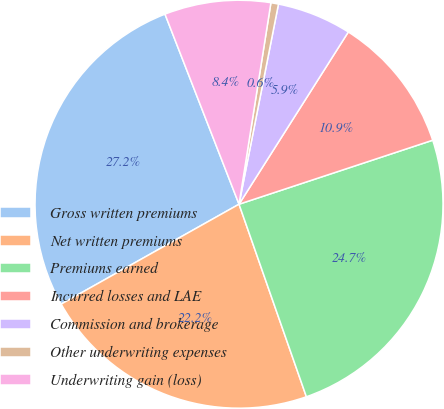Convert chart to OTSL. <chart><loc_0><loc_0><loc_500><loc_500><pie_chart><fcel>Gross written premiums<fcel>Net written premiums<fcel>Premiums earned<fcel>Incurred losses and LAE<fcel>Commission and brokerage<fcel>Other underwriting expenses<fcel>Underwriting gain (loss)<nl><fcel>27.23%<fcel>22.21%<fcel>24.72%<fcel>10.92%<fcel>5.9%<fcel>0.6%<fcel>8.41%<nl></chart> 